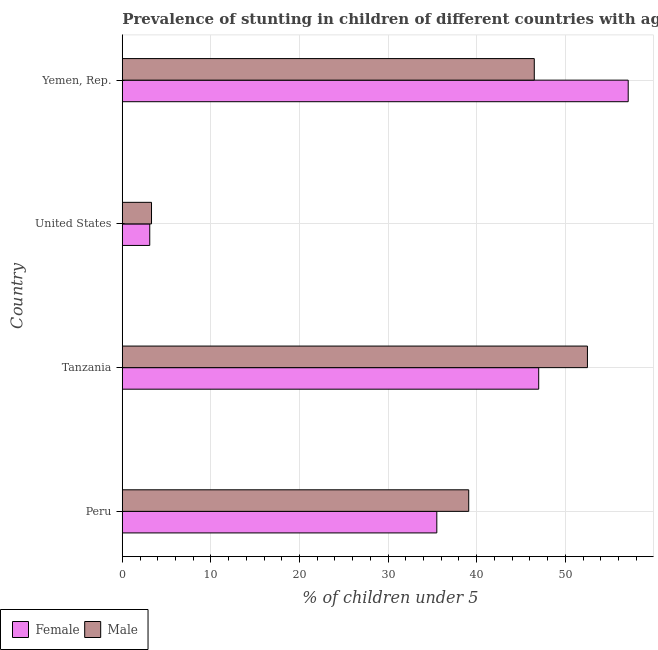How many bars are there on the 2nd tick from the bottom?
Offer a very short reply. 2. What is the label of the 4th group of bars from the top?
Keep it short and to the point. Peru. What is the percentage of stunted male children in Peru?
Your response must be concise. 39.1. Across all countries, what is the maximum percentage of stunted male children?
Give a very brief answer. 52.5. Across all countries, what is the minimum percentage of stunted female children?
Give a very brief answer. 3.1. In which country was the percentage of stunted male children maximum?
Your answer should be very brief. Tanzania. What is the total percentage of stunted male children in the graph?
Ensure brevity in your answer.  141.4. What is the difference between the percentage of stunted male children in Peru and that in United States?
Make the answer very short. 35.8. What is the difference between the percentage of stunted female children in Tanzania and the percentage of stunted male children in United States?
Ensure brevity in your answer.  43.7. What is the average percentage of stunted male children per country?
Offer a terse response. 35.35. What is the difference between the percentage of stunted male children and percentage of stunted female children in Peru?
Offer a very short reply. 3.6. What is the ratio of the percentage of stunted male children in Tanzania to that in United States?
Offer a terse response. 15.91. Is the difference between the percentage of stunted male children in Peru and United States greater than the difference between the percentage of stunted female children in Peru and United States?
Keep it short and to the point. Yes. What is the difference between the highest and the lowest percentage of stunted male children?
Offer a terse response. 49.2. Is the sum of the percentage of stunted male children in Peru and Tanzania greater than the maximum percentage of stunted female children across all countries?
Provide a short and direct response. Yes. What does the 1st bar from the top in Tanzania represents?
Give a very brief answer. Male. How many bars are there?
Keep it short and to the point. 8. How many countries are there in the graph?
Your answer should be compact. 4. What is the difference between two consecutive major ticks on the X-axis?
Your answer should be very brief. 10. Are the values on the major ticks of X-axis written in scientific E-notation?
Keep it short and to the point. No. Does the graph contain any zero values?
Your answer should be compact. No. Does the graph contain grids?
Ensure brevity in your answer.  Yes. How many legend labels are there?
Make the answer very short. 2. What is the title of the graph?
Provide a short and direct response. Prevalence of stunting in children of different countries with age under 5 years. What is the label or title of the X-axis?
Keep it short and to the point.  % of children under 5. What is the  % of children under 5 of Female in Peru?
Ensure brevity in your answer.  35.5. What is the  % of children under 5 of Male in Peru?
Offer a terse response. 39.1. What is the  % of children under 5 of Male in Tanzania?
Ensure brevity in your answer.  52.5. What is the  % of children under 5 in Female in United States?
Make the answer very short. 3.1. What is the  % of children under 5 in Male in United States?
Keep it short and to the point. 3.3. What is the  % of children under 5 in Female in Yemen, Rep.?
Give a very brief answer. 57.1. What is the  % of children under 5 of Male in Yemen, Rep.?
Your answer should be very brief. 46.5. Across all countries, what is the maximum  % of children under 5 in Female?
Provide a short and direct response. 57.1. Across all countries, what is the maximum  % of children under 5 in Male?
Ensure brevity in your answer.  52.5. Across all countries, what is the minimum  % of children under 5 in Female?
Ensure brevity in your answer.  3.1. Across all countries, what is the minimum  % of children under 5 of Male?
Offer a terse response. 3.3. What is the total  % of children under 5 in Female in the graph?
Ensure brevity in your answer.  142.7. What is the total  % of children under 5 in Male in the graph?
Ensure brevity in your answer.  141.4. What is the difference between the  % of children under 5 of Male in Peru and that in Tanzania?
Your answer should be very brief. -13.4. What is the difference between the  % of children under 5 in Female in Peru and that in United States?
Provide a succinct answer. 32.4. What is the difference between the  % of children under 5 of Male in Peru and that in United States?
Ensure brevity in your answer.  35.8. What is the difference between the  % of children under 5 in Female in Peru and that in Yemen, Rep.?
Keep it short and to the point. -21.6. What is the difference between the  % of children under 5 in Female in Tanzania and that in United States?
Offer a very short reply. 43.9. What is the difference between the  % of children under 5 of Male in Tanzania and that in United States?
Provide a succinct answer. 49.2. What is the difference between the  % of children under 5 of Female in Tanzania and that in Yemen, Rep.?
Offer a terse response. -10.1. What is the difference between the  % of children under 5 in Female in United States and that in Yemen, Rep.?
Give a very brief answer. -54. What is the difference between the  % of children under 5 in Male in United States and that in Yemen, Rep.?
Offer a terse response. -43.2. What is the difference between the  % of children under 5 in Female in Peru and the  % of children under 5 in Male in United States?
Offer a terse response. 32.2. What is the difference between the  % of children under 5 of Female in Peru and the  % of children under 5 of Male in Yemen, Rep.?
Provide a succinct answer. -11. What is the difference between the  % of children under 5 in Female in Tanzania and the  % of children under 5 in Male in United States?
Ensure brevity in your answer.  43.7. What is the difference between the  % of children under 5 of Female in Tanzania and the  % of children under 5 of Male in Yemen, Rep.?
Give a very brief answer. 0.5. What is the difference between the  % of children under 5 of Female in United States and the  % of children under 5 of Male in Yemen, Rep.?
Your response must be concise. -43.4. What is the average  % of children under 5 of Female per country?
Offer a terse response. 35.67. What is the average  % of children under 5 in Male per country?
Offer a very short reply. 35.35. What is the difference between the  % of children under 5 in Female and  % of children under 5 in Male in Peru?
Ensure brevity in your answer.  -3.6. What is the difference between the  % of children under 5 in Female and  % of children under 5 in Male in Yemen, Rep.?
Keep it short and to the point. 10.6. What is the ratio of the  % of children under 5 of Female in Peru to that in Tanzania?
Your answer should be compact. 0.76. What is the ratio of the  % of children under 5 of Male in Peru to that in Tanzania?
Offer a very short reply. 0.74. What is the ratio of the  % of children under 5 of Female in Peru to that in United States?
Offer a very short reply. 11.45. What is the ratio of the  % of children under 5 of Male in Peru to that in United States?
Provide a succinct answer. 11.85. What is the ratio of the  % of children under 5 in Female in Peru to that in Yemen, Rep.?
Your answer should be very brief. 0.62. What is the ratio of the  % of children under 5 of Male in Peru to that in Yemen, Rep.?
Keep it short and to the point. 0.84. What is the ratio of the  % of children under 5 in Female in Tanzania to that in United States?
Make the answer very short. 15.16. What is the ratio of the  % of children under 5 in Male in Tanzania to that in United States?
Ensure brevity in your answer.  15.91. What is the ratio of the  % of children under 5 of Female in Tanzania to that in Yemen, Rep.?
Your response must be concise. 0.82. What is the ratio of the  % of children under 5 in Male in Tanzania to that in Yemen, Rep.?
Offer a terse response. 1.13. What is the ratio of the  % of children under 5 of Female in United States to that in Yemen, Rep.?
Make the answer very short. 0.05. What is the ratio of the  % of children under 5 of Male in United States to that in Yemen, Rep.?
Give a very brief answer. 0.07. What is the difference between the highest and the second highest  % of children under 5 of Female?
Offer a terse response. 10.1. What is the difference between the highest and the second highest  % of children under 5 in Male?
Your answer should be compact. 6. What is the difference between the highest and the lowest  % of children under 5 in Male?
Make the answer very short. 49.2. 